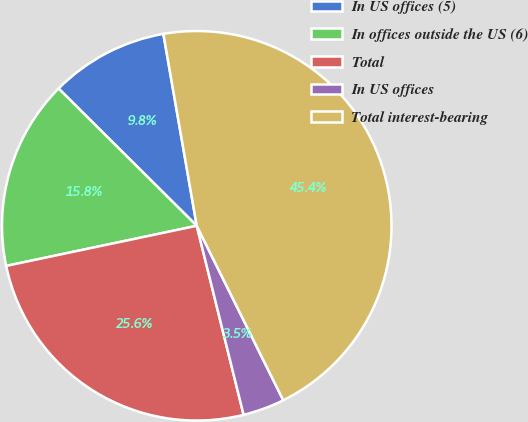Convert chart to OTSL. <chart><loc_0><loc_0><loc_500><loc_500><pie_chart><fcel>In US offices (5)<fcel>In offices outside the US (6)<fcel>Total<fcel>In US offices<fcel>Total interest-bearing<nl><fcel>9.81%<fcel>15.75%<fcel>25.56%<fcel>3.46%<fcel>45.41%<nl></chart> 